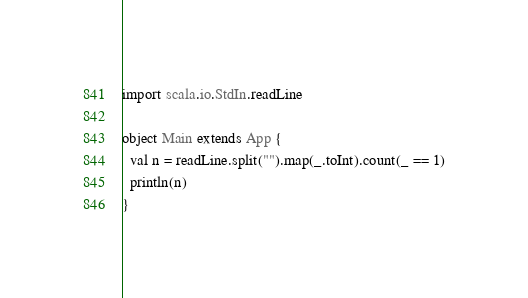<code> <loc_0><loc_0><loc_500><loc_500><_Scala_>import scala.io.StdIn.readLine

object Main extends App {
  val n = readLine.split("").map(_.toInt).count(_ == 1)
  println(n)
}</code> 